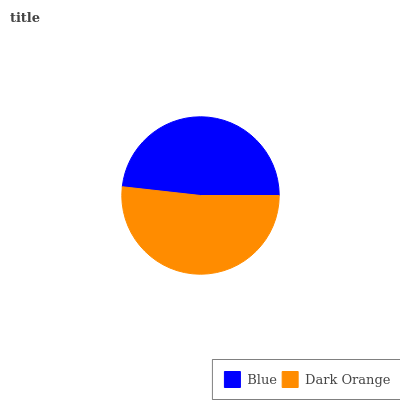Is Blue the minimum?
Answer yes or no. Yes. Is Dark Orange the maximum?
Answer yes or no. Yes. Is Dark Orange the minimum?
Answer yes or no. No. Is Dark Orange greater than Blue?
Answer yes or no. Yes. Is Blue less than Dark Orange?
Answer yes or no. Yes. Is Blue greater than Dark Orange?
Answer yes or no. No. Is Dark Orange less than Blue?
Answer yes or no. No. Is Dark Orange the high median?
Answer yes or no. Yes. Is Blue the low median?
Answer yes or no. Yes. Is Blue the high median?
Answer yes or no. No. Is Dark Orange the low median?
Answer yes or no. No. 